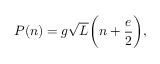Convert formula to latex. <formula><loc_0><loc_0><loc_500><loc_500>P ( n ) = g \sqrt { L } \left ( n + \frac { e } { 2 } \right ) ,</formula> 